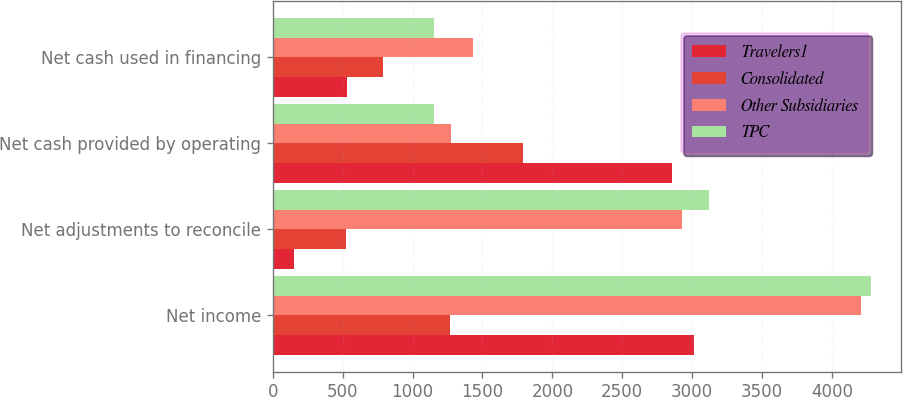Convert chart. <chart><loc_0><loc_0><loc_500><loc_500><stacked_bar_chart><ecel><fcel>Net income<fcel>Net adjustments to reconcile<fcel>Net cash provided by operating<fcel>Net cash used in financing<nl><fcel>Travelers1<fcel>3012<fcel>153<fcel>2859<fcel>531<nl><fcel>Consolidated<fcel>1267<fcel>525<fcel>1792<fcel>788<nl><fcel>Other Subsidiaries<fcel>4208<fcel>2930<fcel>1278<fcel>1429<nl><fcel>TPC<fcel>4279<fcel>3124<fcel>1155<fcel>1155<nl></chart> 